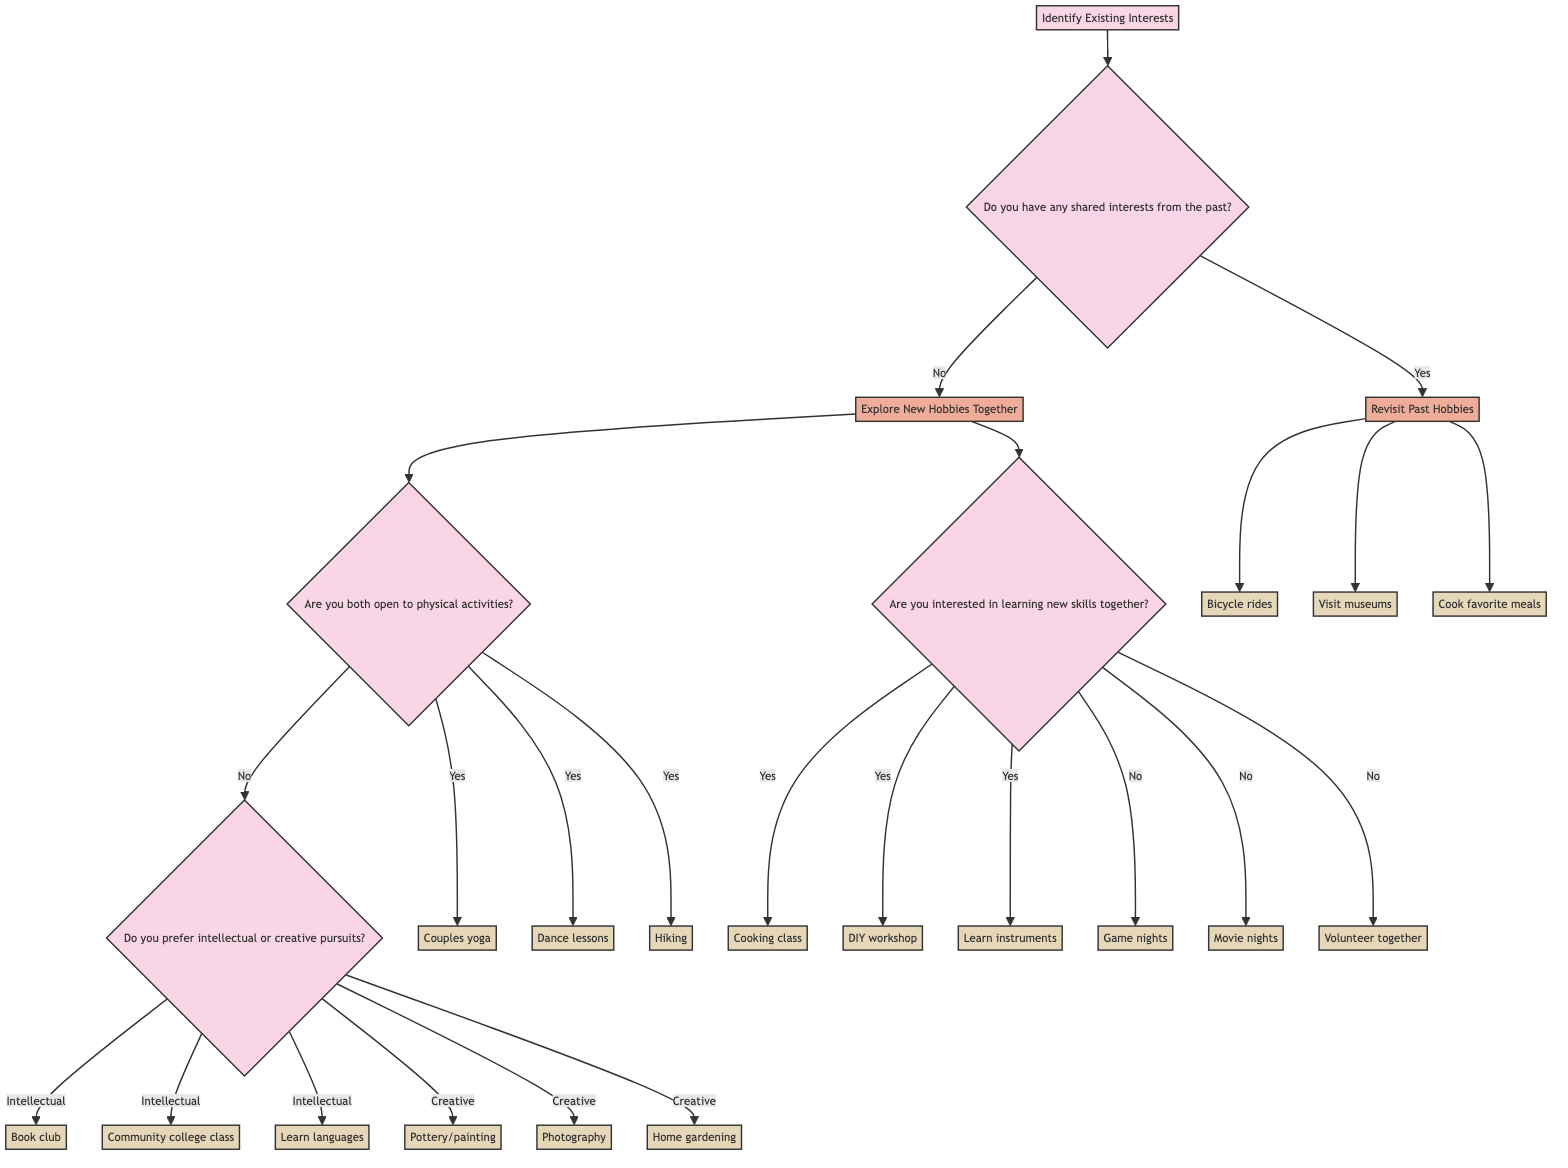What is the starting point of the decision tree? The decision tree starts at the node labeled "Identify Existing Interests." This is the first action that leads to further questions and decisions.
Answer: Identify Existing Interests How many main decisions are there after identifying existing interests? There are two main decisions after identifying existing interests: whether there are shared interests from the past or if the couple should explore new hobbies together.
Answer: 2 What follows if there are shared interests from the past? If there are shared interests from the past, the couple will engage in "Revisit Past Hobbies." This leads to several specific activities they can choose from.
Answer: Revisit Past Hobbies What activities are suggested if the couple is open to physical activities? If the couple is open to physical activities, the suggested activities include joining a couples yoga class, taking dance lessons, or starting to hike.
Answer: Couples yoga class, dance lessons, hiking What activities can the couple explore if they don't prefer physical activities and favor intellectual pursuits? If the couple prefers intellectual pursuits over physical activities, the suggested activities include attending local book club meetings, taking a history or art class, or exploring new languages through online courses.
Answer: Book club meetings, community college class, learn languages If the couple decides to explore new hobbies together and is not interested in learning new skills, what activities can they engage in? If they are not interested in learning new skills, they can engage in activities such as having regular game nights, setting up movie nights, or volunteering together at local charities.
Answer: Game nights, movie nights, volunteering together What is the next question to be answered if the couple is interested in learning new skills together? If the couple is interested in learning new skills together, the next question that arises is about what specific activities they might take part in, which include taking a cooking class, joining a DIY workshop, or learning to play musical instruments.
Answer: Yes What type of decisions does the node 'Explore New Hobbies Together' lead to? The node 'Explore New Hobbies Together' leads to decisions regarding whether the couple is open to physical activities or interested in learning new skills together.
Answer: Physical activities, learning new skills 